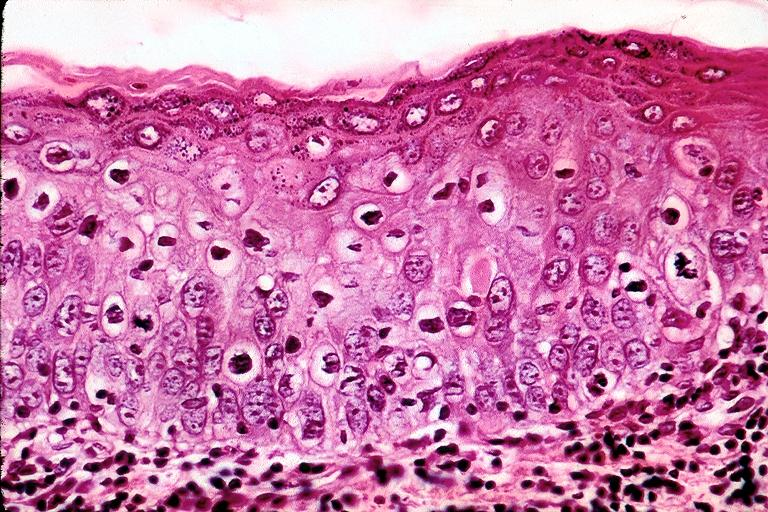s oral present?
Answer the question using a single word or phrase. Yes 